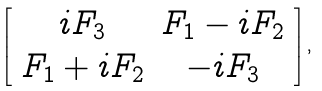Convert formula to latex. <formula><loc_0><loc_0><loc_500><loc_500>\left [ \begin{array} { c c } i F _ { 3 } & F _ { 1 } - i F _ { 2 } \\ F _ { 1 } + i F _ { 2 } & - i F _ { 3 } \end{array} \right ] ,</formula> 